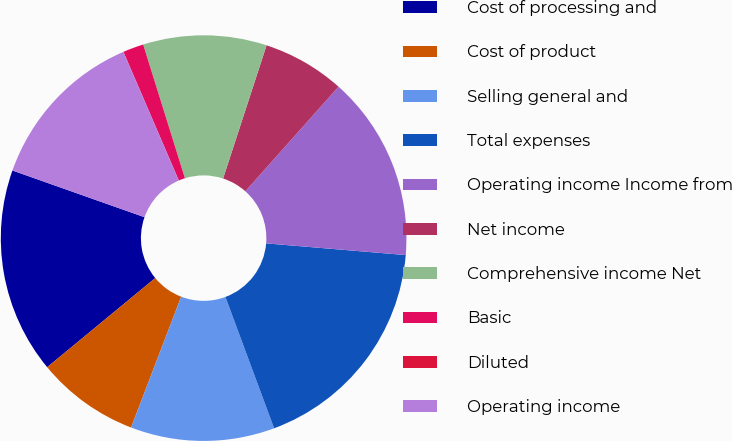Convert chart. <chart><loc_0><loc_0><loc_500><loc_500><pie_chart><fcel>Cost of processing and<fcel>Cost of product<fcel>Selling general and<fcel>Total expenses<fcel>Operating income Income from<fcel>Net income<fcel>Comprehensive income Net<fcel>Basic<fcel>Diluted<fcel>Operating income<nl><fcel>16.39%<fcel>8.2%<fcel>11.47%<fcel>18.02%<fcel>14.75%<fcel>6.56%<fcel>9.84%<fcel>1.65%<fcel>0.01%<fcel>13.11%<nl></chart> 